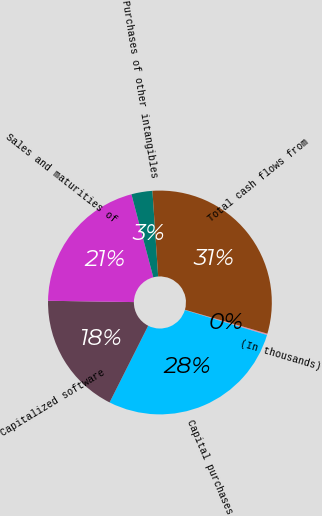<chart> <loc_0><loc_0><loc_500><loc_500><pie_chart><fcel>(In thousands)<fcel>Capital purchases<fcel>Capitalized software<fcel>Sales and maturities of<fcel>Purchases of other intangibles<fcel>Total cash flows from<nl><fcel>0.2%<fcel>27.73%<fcel>17.82%<fcel>20.66%<fcel>3.03%<fcel>30.56%<nl></chart> 